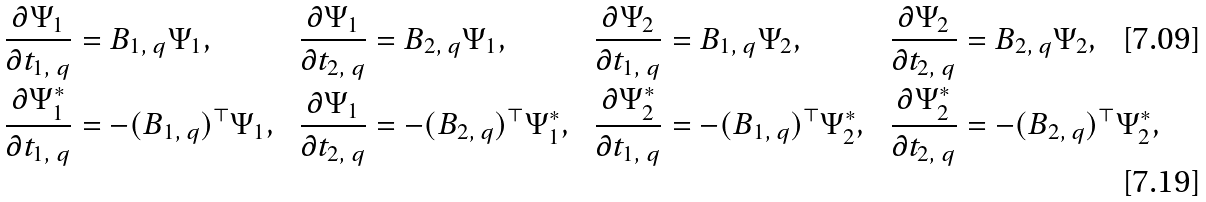Convert formula to latex. <formula><loc_0><loc_0><loc_500><loc_500>\frac { \partial \Psi _ { 1 } } { \partial t _ { 1 , \ q } } & = B _ { 1 , \ q } \Psi _ { 1 } , & \frac { \partial \Psi _ { 1 } } { \partial t _ { 2 , \ q } } & = B _ { 2 , \ q } \Psi _ { 1 } , & \frac { \partial \Psi _ { 2 } } { \partial t _ { 1 , \ q } } & = B _ { 1 , \ q } \Psi _ { 2 } , & \frac { \partial \Psi _ { 2 } } { \partial t _ { 2 , \ q } } & = B _ { 2 , \ q } \Psi _ { 2 } , \\ \frac { \partial \Psi _ { 1 } ^ { * } } { \partial t _ { 1 , \ q } } & = - ( B _ { 1 , \ q } ) ^ { \top } \Psi _ { 1 } , & \frac { \partial \Psi _ { 1 } } { \partial t _ { 2 , \ q } } & = - ( B _ { 2 , \ q } ) ^ { \top } \Psi ^ { * } _ { 1 } , & \frac { \partial \Psi _ { 2 } ^ { * } } { \partial t _ { 1 , \ q } } & = - ( B _ { 1 , \ q } ) ^ { \top } \Psi ^ { * } _ { 2 } , & \frac { \partial \Psi ^ { * } _ { 2 } } { \partial t _ { 2 , \ q } } & = - ( B _ { 2 , \ q } ) ^ { \top } \Psi ^ { * } _ { 2 } ,</formula> 